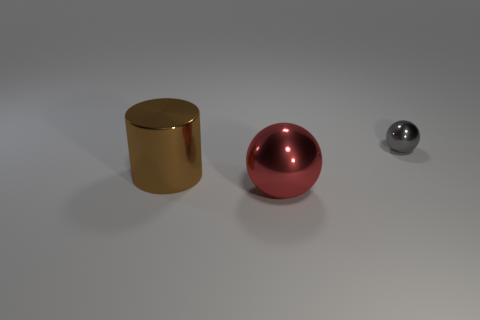Do the gray metal object and the big thing that is on the right side of the cylinder have the same shape? No, they do not have the same shape. The gray object appears to be a small sphere, while the larger object on the right side of the cylinder is spherical but much bigger, indicating a difference in scale rather than shape. They share a spherical quality, but their size is what differentiates them substantially. 